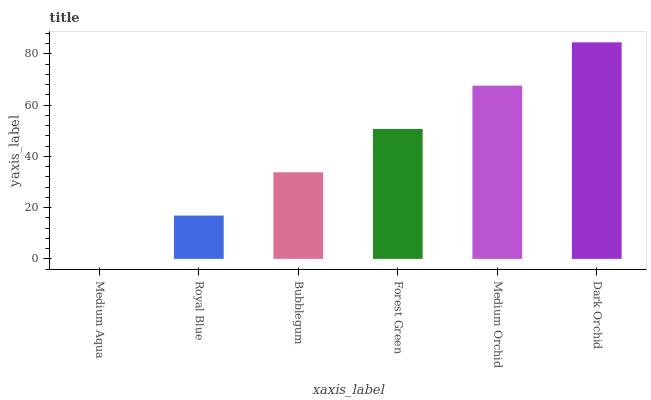Is Royal Blue the minimum?
Answer yes or no. No. Is Royal Blue the maximum?
Answer yes or no. No. Is Royal Blue greater than Medium Aqua?
Answer yes or no. Yes. Is Medium Aqua less than Royal Blue?
Answer yes or no. Yes. Is Medium Aqua greater than Royal Blue?
Answer yes or no. No. Is Royal Blue less than Medium Aqua?
Answer yes or no. No. Is Forest Green the high median?
Answer yes or no. Yes. Is Bubblegum the low median?
Answer yes or no. Yes. Is Medium Aqua the high median?
Answer yes or no. No. Is Royal Blue the low median?
Answer yes or no. No. 